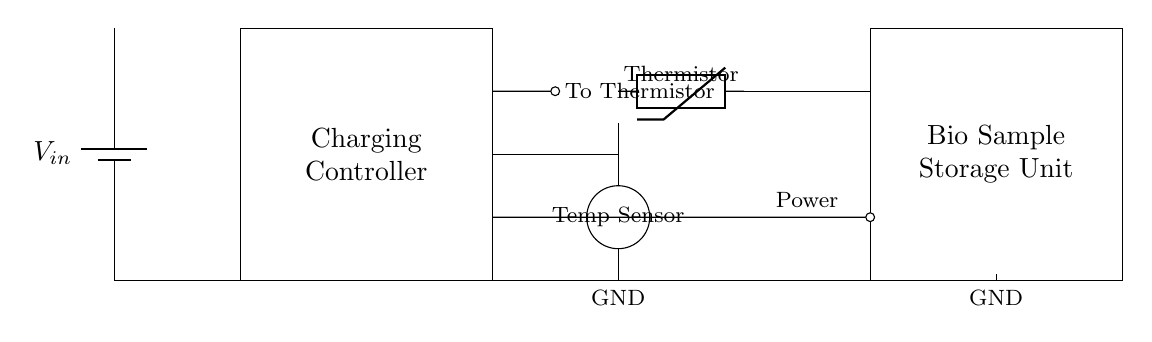What does the rectangular box labeled 'Charging Controller' represent? The rectangular box represents the charging controller that manages the charging process for the biological sample storage unit to ensure it operates under optimal conditions.
Answer: Charging Controller What is the function of the thermistor in this circuit? The thermistor is used to measure temperature; it alters resistance based on temperature changes, which helps control the charging process to protect sensitive biological samples.
Answer: Measure temperature What power source is used in this circuit? The circuit uses a battery as the power source, indicated by the battery symbol and labeled as \( V_{in} \).
Answer: Battery How many connection points are there from the charging controller to the temperature sensor? There are two connection points leading from the charging controller to the temperature sensor, one for the power and one for the feedback.
Answer: Two What does the ground connection indicate in this circuit? The ground connection indicates a common return path for current and serves as a reference point for the circuit's voltage levels, ensuring safe operation.
Answer: Common ground What happens to the biological sample storage unit if the temperature exceeds a certain threshold? If the temperature exceeds a certain threshold, the charging controller will likely stop charging or adjust parameters to protect the samples, ensuring their stability and integrity.
Answer: Stop charging 